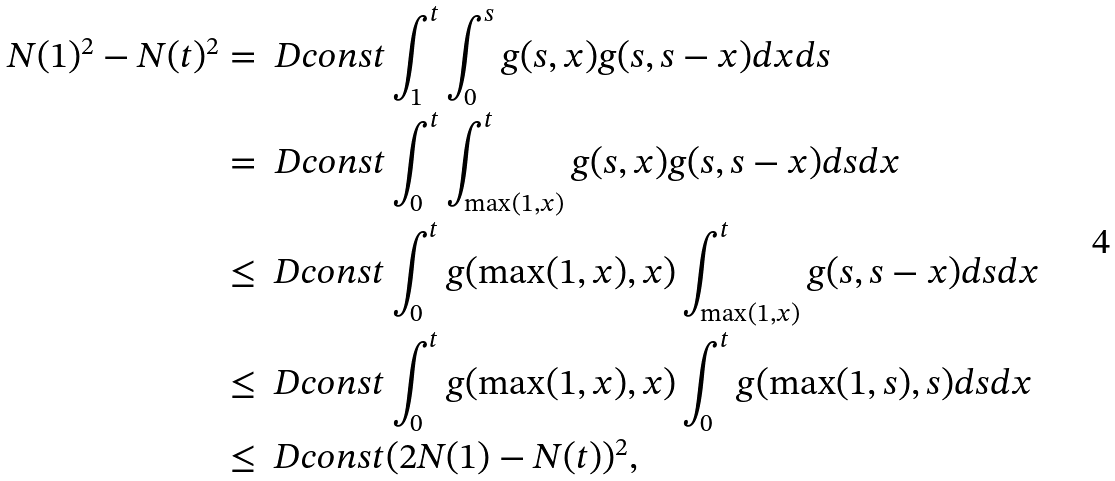<formula> <loc_0><loc_0><loc_500><loc_500>N ( 1 ) ^ { 2 } - N ( t ) ^ { 2 } & = { \ D c o n s t } \int _ { 1 } ^ { t } \int _ { 0 } ^ { s } g ( s , x ) g ( s , s - x ) d x d s \\ & = { \ D c o n s t } \int _ { 0 } ^ { t } \int _ { \max ( 1 , x ) } ^ { t } g ( s , x ) g ( s , s - x ) d s d x \\ & \leq { \ D c o n s t } \int _ { 0 } ^ { t } g ( \max ( 1 , x ) , x ) \int _ { \max ( 1 , x ) } ^ { t } g ( s , s - x ) d s d x \\ & \leq { \ D c o n s t } \int _ { 0 } ^ { t } g ( \max ( 1 , x ) , x ) \int _ { 0 } ^ { t } g ( \max ( 1 , s ) , s ) d s d x \\ & \leq { \ D c o n s t } ( 2 N ( 1 ) - N ( t ) ) ^ { 2 } ,</formula> 